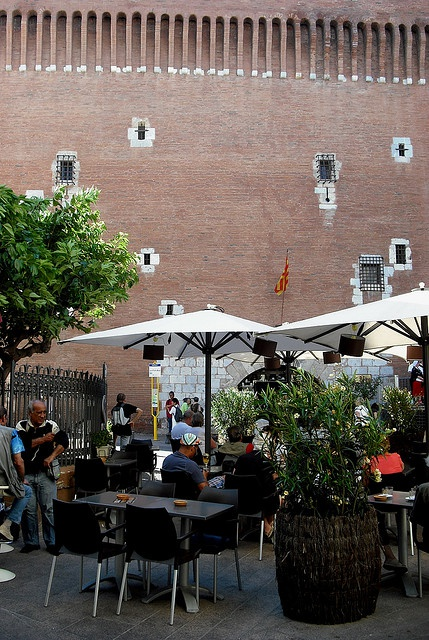Describe the objects in this image and their specific colors. I can see potted plant in darkgray, black, darkgreen, and gray tones, chair in darkgray, black, gray, and darkblue tones, umbrella in darkgray, white, gray, and black tones, umbrella in darkgray, white, black, and gray tones, and people in darkgray, black, gray, maroon, and purple tones in this image. 